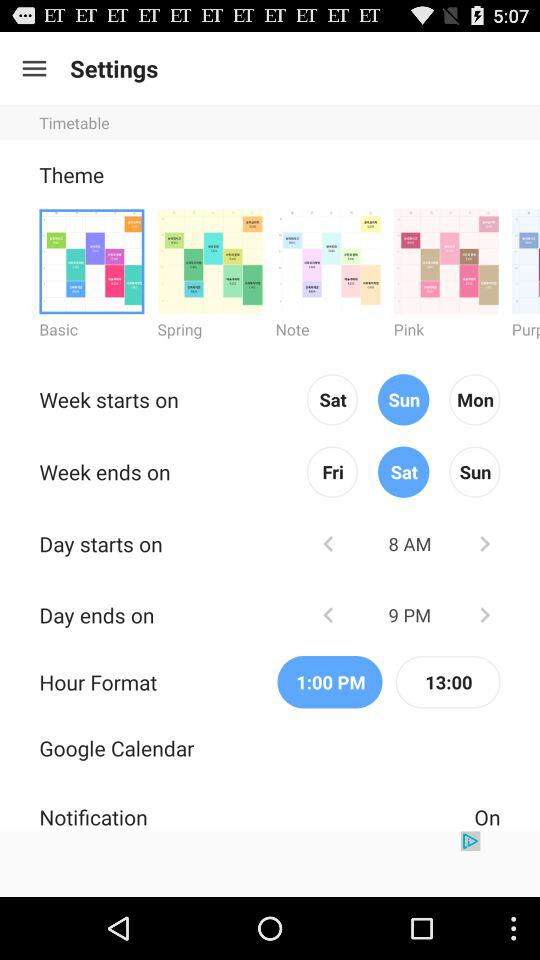What is the status of "Notification"? The status is "on". 